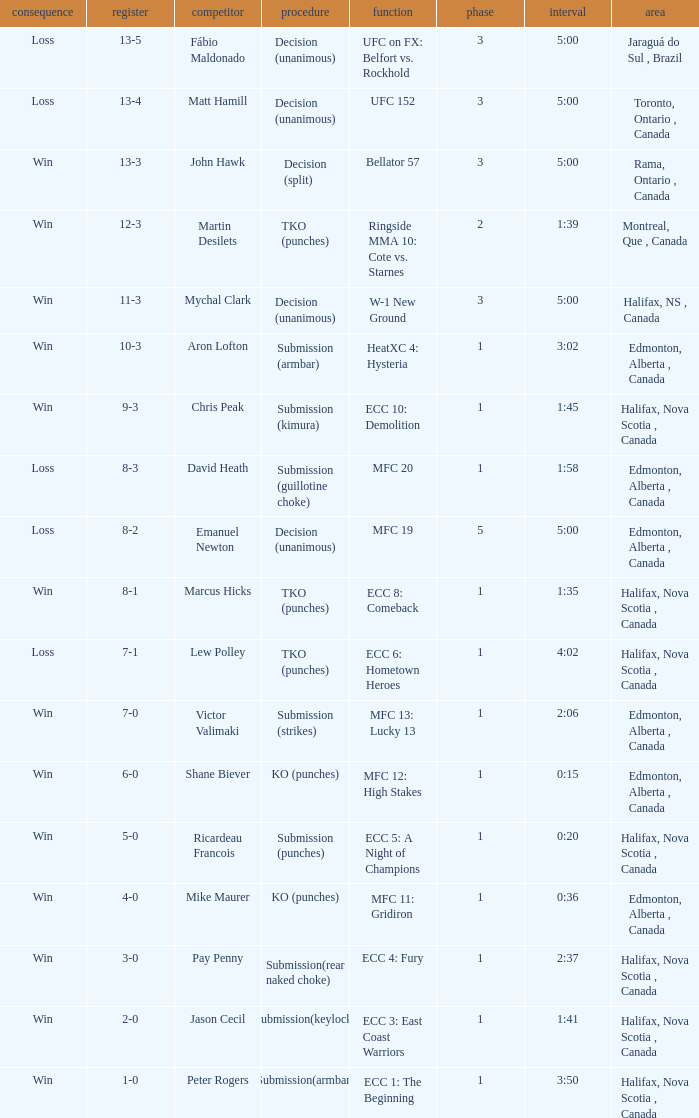Who is the opponent of the match with a win result and a time of 3:02? Aron Lofton. 